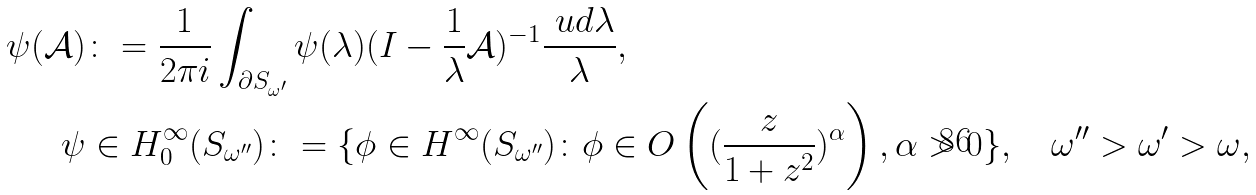<formula> <loc_0><loc_0><loc_500><loc_500>\psi ( \mathcal { A } ) & \colon = \frac { 1 } { 2 \pi i } \int _ { \partial S _ { \omega ^ { \prime } } } \psi ( \lambda ) ( I - \frac { 1 } { \lambda } \mathcal { A } ) ^ { - 1 } \frac { \ u d \lambda } { \lambda } , \\ \psi & \in H ^ { \infty } _ { 0 } ( S _ { \omega ^ { \prime \prime } } ) \colon = \{ \phi \in H ^ { \infty } ( S _ { \omega ^ { \prime \prime } } ) \colon \phi \in O \left ( ( \frac { z } { 1 + z ^ { 2 } } ) ^ { \alpha } \right ) , \alpha > 0 \} , \quad \omega ^ { \prime \prime } > \omega ^ { \prime } > \omega ,</formula> 